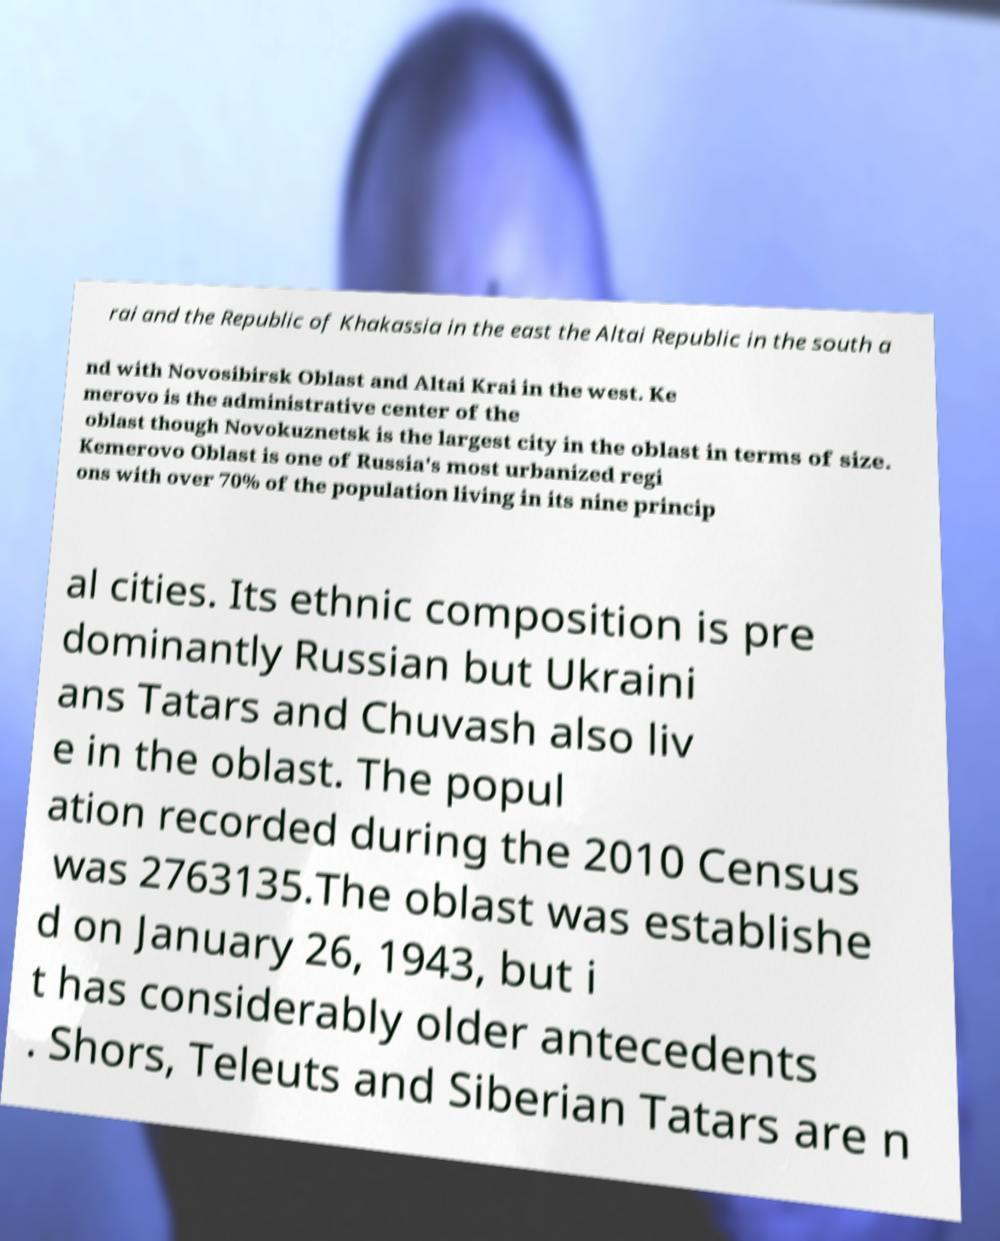There's text embedded in this image that I need extracted. Can you transcribe it verbatim? rai and the Republic of Khakassia in the east the Altai Republic in the south a nd with Novosibirsk Oblast and Altai Krai in the west. Ke merovo is the administrative center of the oblast though Novokuznetsk is the largest city in the oblast in terms of size. Kemerovo Oblast is one of Russia's most urbanized regi ons with over 70% of the population living in its nine princip al cities. Its ethnic composition is pre dominantly Russian but Ukraini ans Tatars and Chuvash also liv e in the oblast. The popul ation recorded during the 2010 Census was 2763135.The oblast was establishe d on January 26, 1943, but i t has considerably older antecedents . Shors, Teleuts and Siberian Tatars are n 